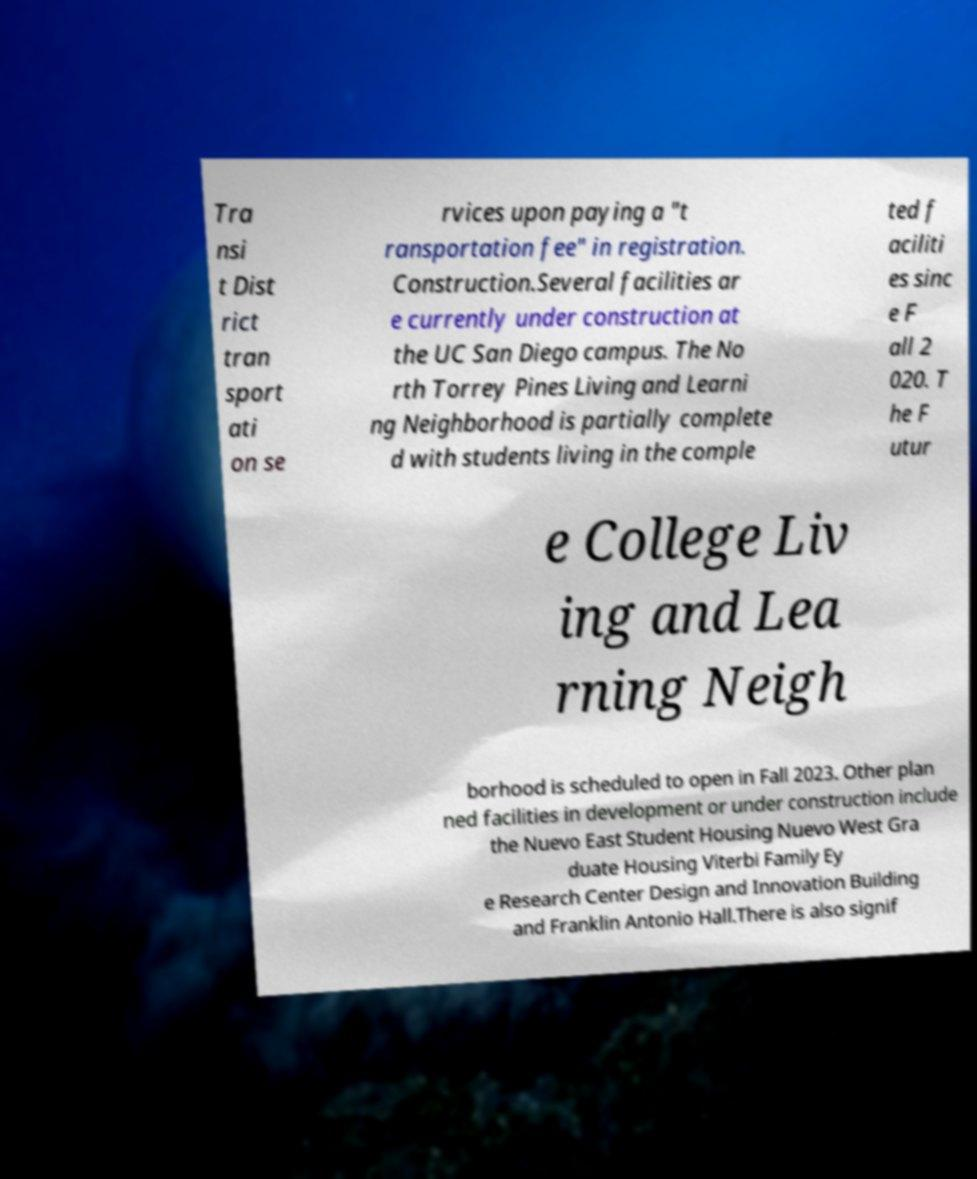Can you accurately transcribe the text from the provided image for me? Tra nsi t Dist rict tran sport ati on se rvices upon paying a "t ransportation fee" in registration. Construction.Several facilities ar e currently under construction at the UC San Diego campus. The No rth Torrey Pines Living and Learni ng Neighborhood is partially complete d with students living in the comple ted f aciliti es sinc e F all 2 020. T he F utur e College Liv ing and Lea rning Neigh borhood is scheduled to open in Fall 2023. Other plan ned facilities in development or under construction include the Nuevo East Student Housing Nuevo West Gra duate Housing Viterbi Family Ey e Research Center Design and Innovation Building and Franklin Antonio Hall.There is also signif 